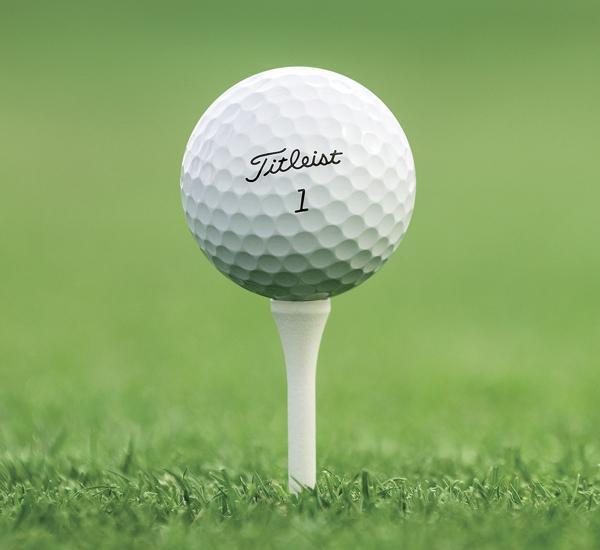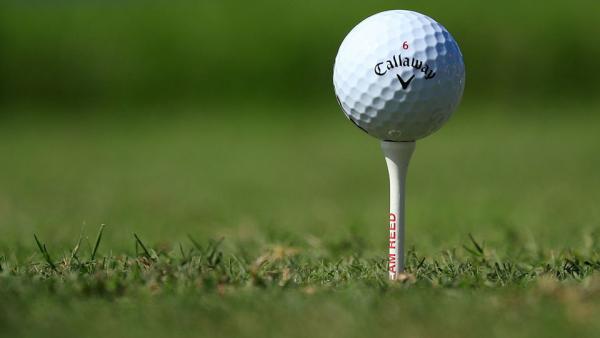The first image is the image on the left, the second image is the image on the right. Examine the images to the left and right. Is the description "One of the images shows a golf ball on the grass." accurate? Answer yes or no. No. 